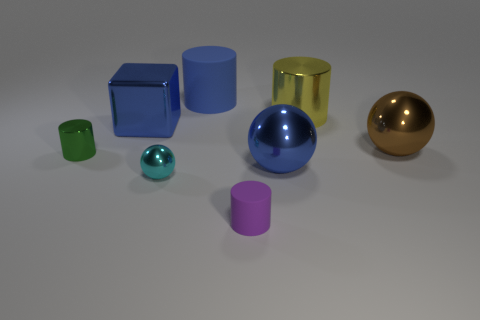What number of large yellow metal things are the same shape as the cyan metal object?
Offer a very short reply. 0. What shape is the metallic thing that is in front of the big metal ball on the left side of the yellow thing?
Make the answer very short. Sphere. There is a metal cylinder that is to the left of the blue metallic ball; does it have the same size as the blue shiny cube?
Your response must be concise. No. There is a shiny object that is behind the tiny green thing and left of the yellow cylinder; what size is it?
Make the answer very short. Large. What number of cyan metallic balls are the same size as the purple cylinder?
Your response must be concise. 1. How many metal cylinders are left of the metal cylinder that is behind the small shiny cylinder?
Offer a very short reply. 1. Is the color of the metal cylinder in front of the large brown ball the same as the metallic cube?
Your response must be concise. No. Are there any metal cylinders that are behind the matte cylinder on the left side of the tiny cylinder that is in front of the cyan sphere?
Your response must be concise. No. There is a blue thing that is right of the cyan shiny object and left of the blue metallic sphere; what is its shape?
Give a very brief answer. Cylinder. Is there a sphere of the same color as the big rubber thing?
Your answer should be compact. Yes. 